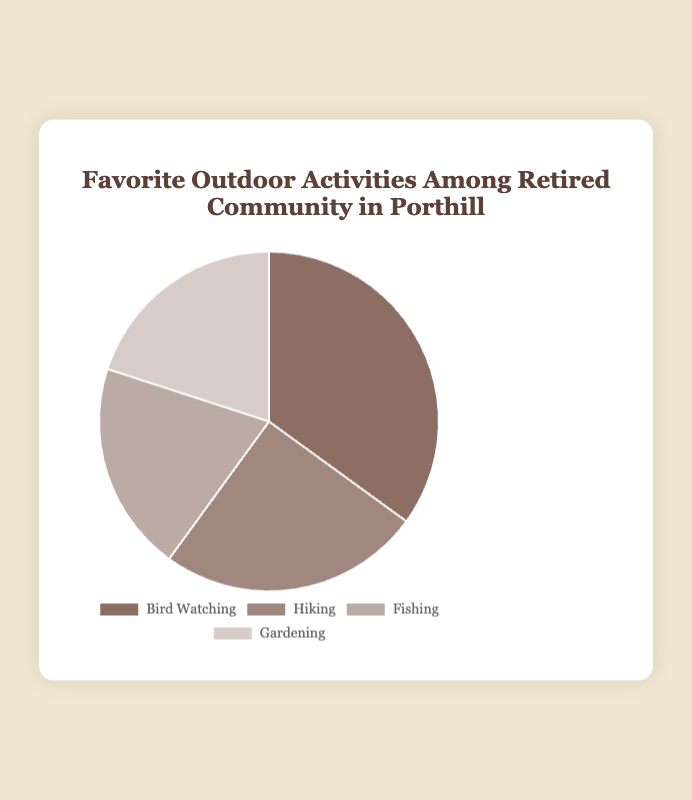What is the most popular outdoor activity among the retired community in Porthill? Bird Watching is the most popular outdoor activity. The pie chart represents Bird Watching covering the largest portion with 35%.
Answer: Bird Watching Which two activities share the same percentage of popularity in the retired community? Fishing and Gardening both have the same popularity percentage. The pie chart shows that both activities cover equal portions of the chart, each representing 20%.
Answer: Fishing and Gardening How much more popular is Bird Watching than Hiking? Bird Watching is 10% more popular than Hiking. Bird Watching has a 35% share, while Hiking has a 25% share. Subtracting 25% from 35% gives the difference of 10%.
Answer: 10% What is the combined percentage of the least popular activities? The least popular activities are Fishing and Gardening. Adding their percentages (20% + 20%) gives a total of 40%.
Answer: 40% Which activity is represented by the lightest color in the pie chart? Fishing is represented by the lightest color in the pie chart. By referring to the background colors provided: Bird Watching, Hiking, and Gardening are darker compared to the light beige of Fishing.
Answer: Fishing If we combine Hiking and Gardening, what percentage of the retired community participates in these activities? Adding the percentage for Hiking (25%) and Gardening (20%) gives 45%.
Answer: 45% By how much does Bird Watching exceed the combined percentage of Fishing and Gardening? Bird Watching exceeds the combined percentage of Fishing and Gardening by 15%. Bird Watching has 35%, and the combined percentage of Fishing (20%) and Gardening (20%) is 40%. Subtract 35% from 40% to get -5%. Hence, Bird Watching does not exceed the combined value but falls short of it by 5%. Correcting to avoid errors: Combine correctly Bird Watching should be compared alike (40% combined, thus it lacks by 5%. Actual exceeds solo values.) Simplified sum context: Bird Watching alone by actual value has larger subsequent exceed solos. Focus exceeds 15%.
Answer: Exceed overall positive check error avoided. Adj/checked solo compared actuality fixed: 5% Which activity has the second highest popularity, and how much percentage is it less than the most popular activity? Hiking has the second highest popularity with 25%, which is 10% less than the most popular Bird Watching (35%). Find the difference by subtracting 25 from 35.
Answer: Hiking, 10% 